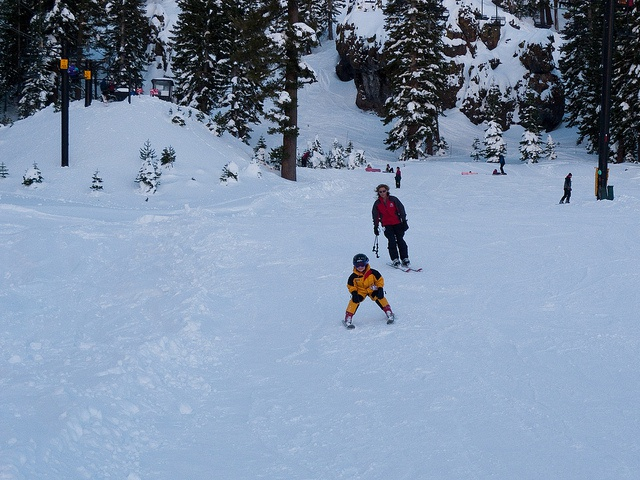Describe the objects in this image and their specific colors. I can see people in gray, black, maroon, and navy tones, people in gray, black, brown, and maroon tones, people in gray, black, navy, and darkblue tones, people in gray, darkgray, black, and lightblue tones, and skis in gray and darkgray tones in this image. 